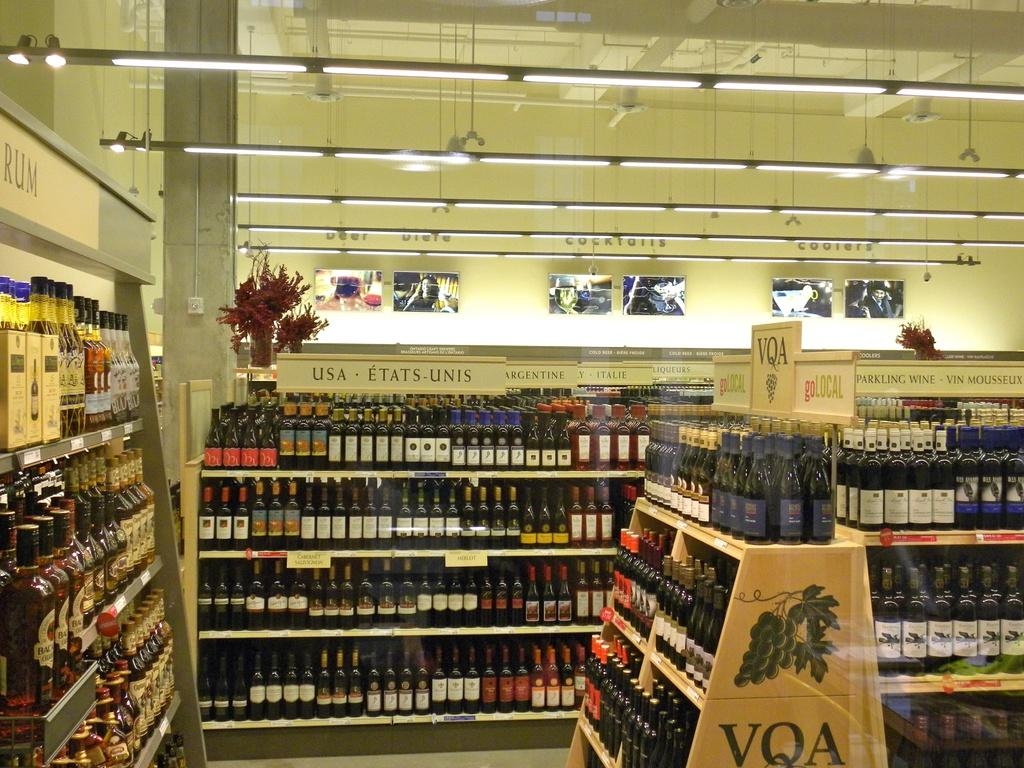<image>
Summarize the visual content of the image. An aisle in a liquor store which has the bottles all on shelves under signs depicting the region that they came from. 